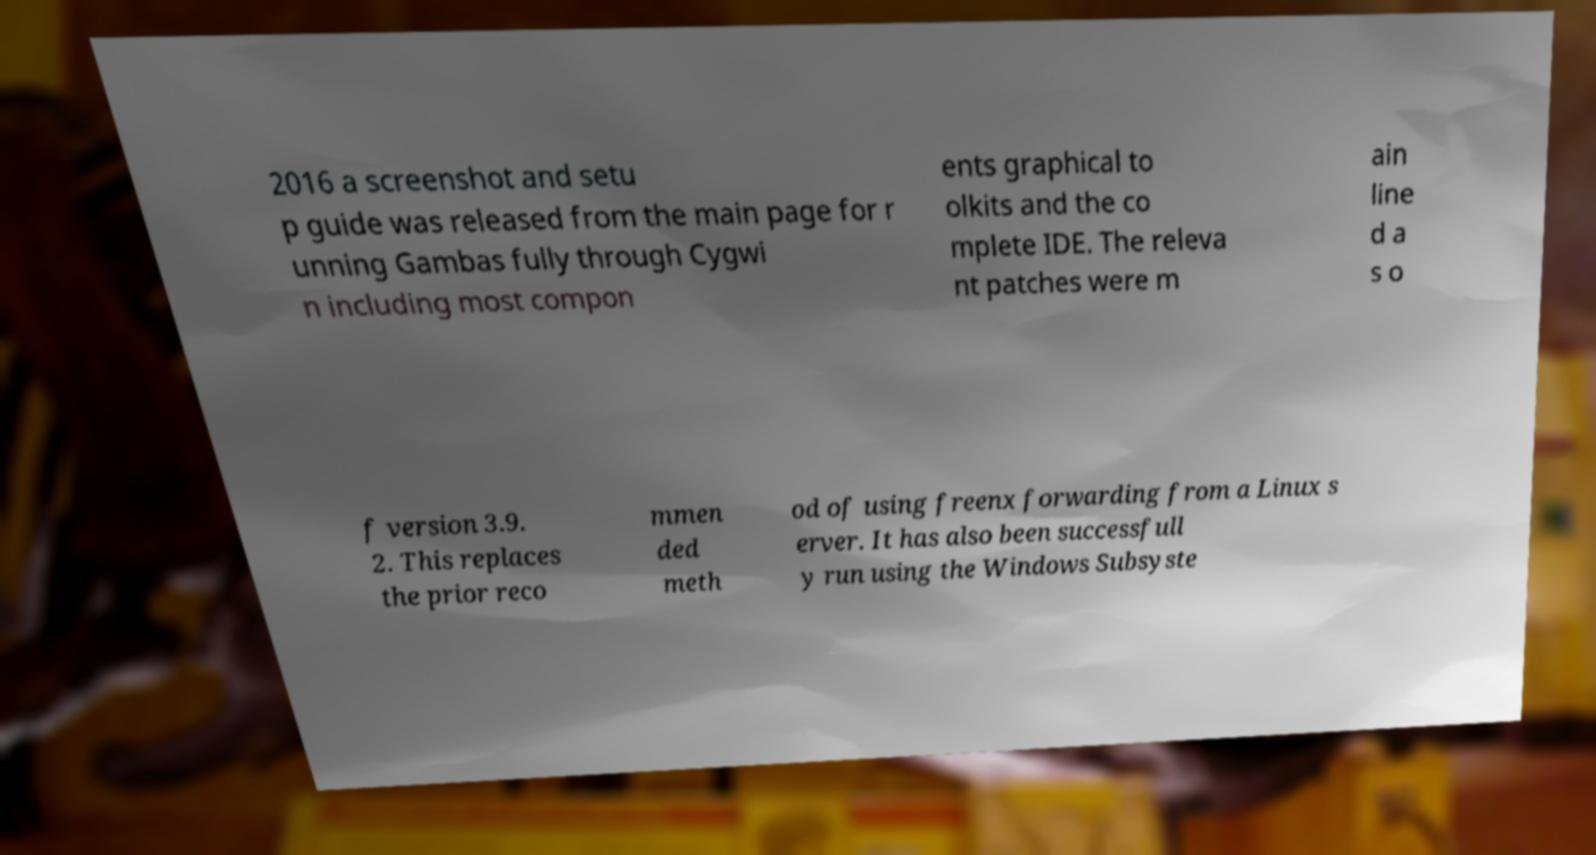For documentation purposes, I need the text within this image transcribed. Could you provide that? 2016 a screenshot and setu p guide was released from the main page for r unning Gambas fully through Cygwi n including most compon ents graphical to olkits and the co mplete IDE. The releva nt patches were m ain line d a s o f version 3.9. 2. This replaces the prior reco mmen ded meth od of using freenx forwarding from a Linux s erver. It has also been successfull y run using the Windows Subsyste 